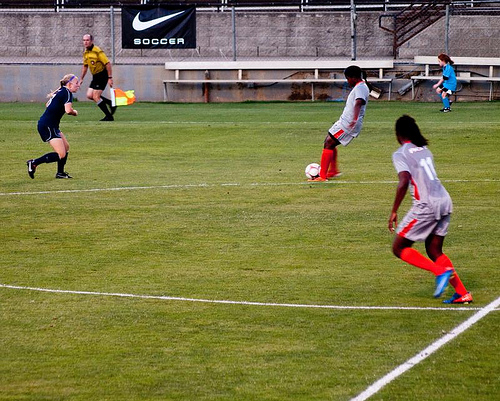<image>
Is there a player on the bench? No. The player is not positioned on the bench. They may be near each other, but the player is not supported by or resting on top of the bench. 